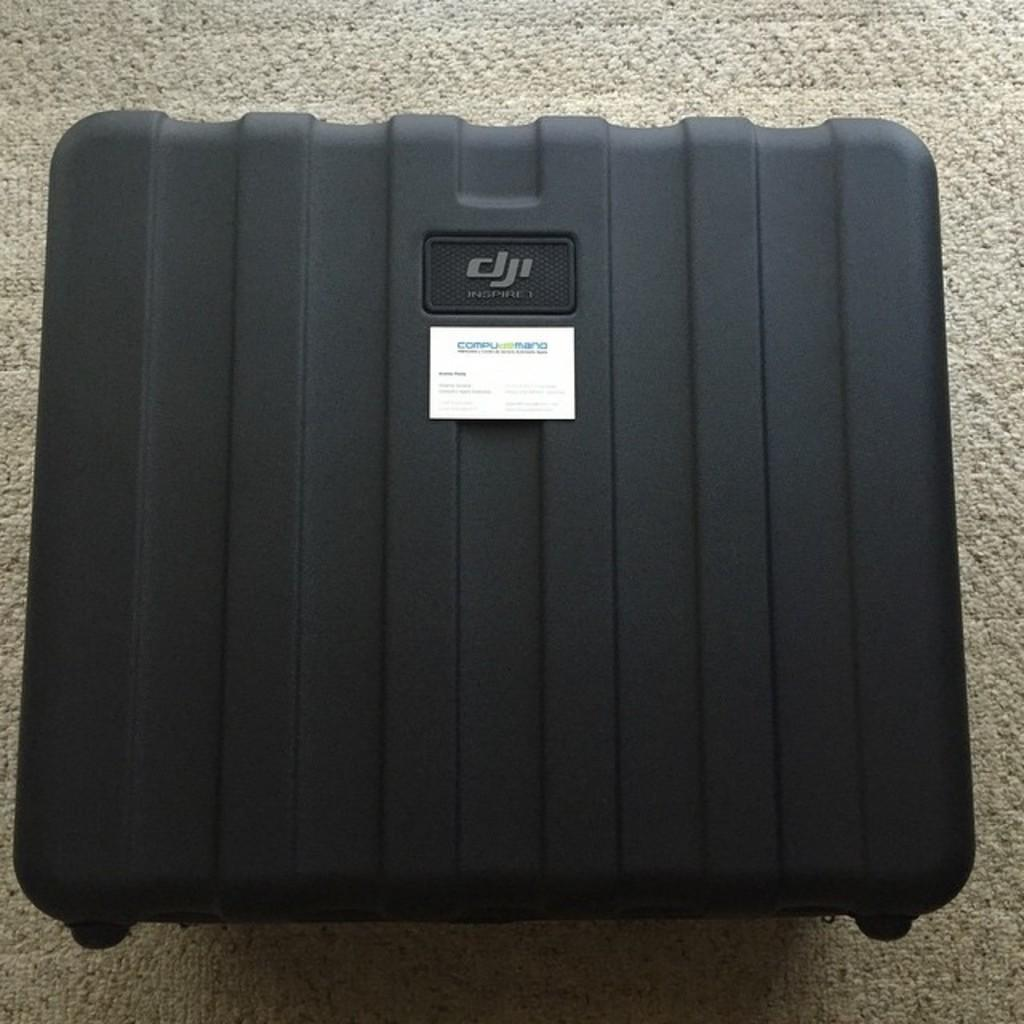What type of object is the main subject in the image? There is a black briefcase in the image. Is there any additional information about the briefcase? Yes, there is a paper tag on the briefcase. How many women are present in the image? There is no information about women in the image; it only features a black briefcase with a paper tag. 